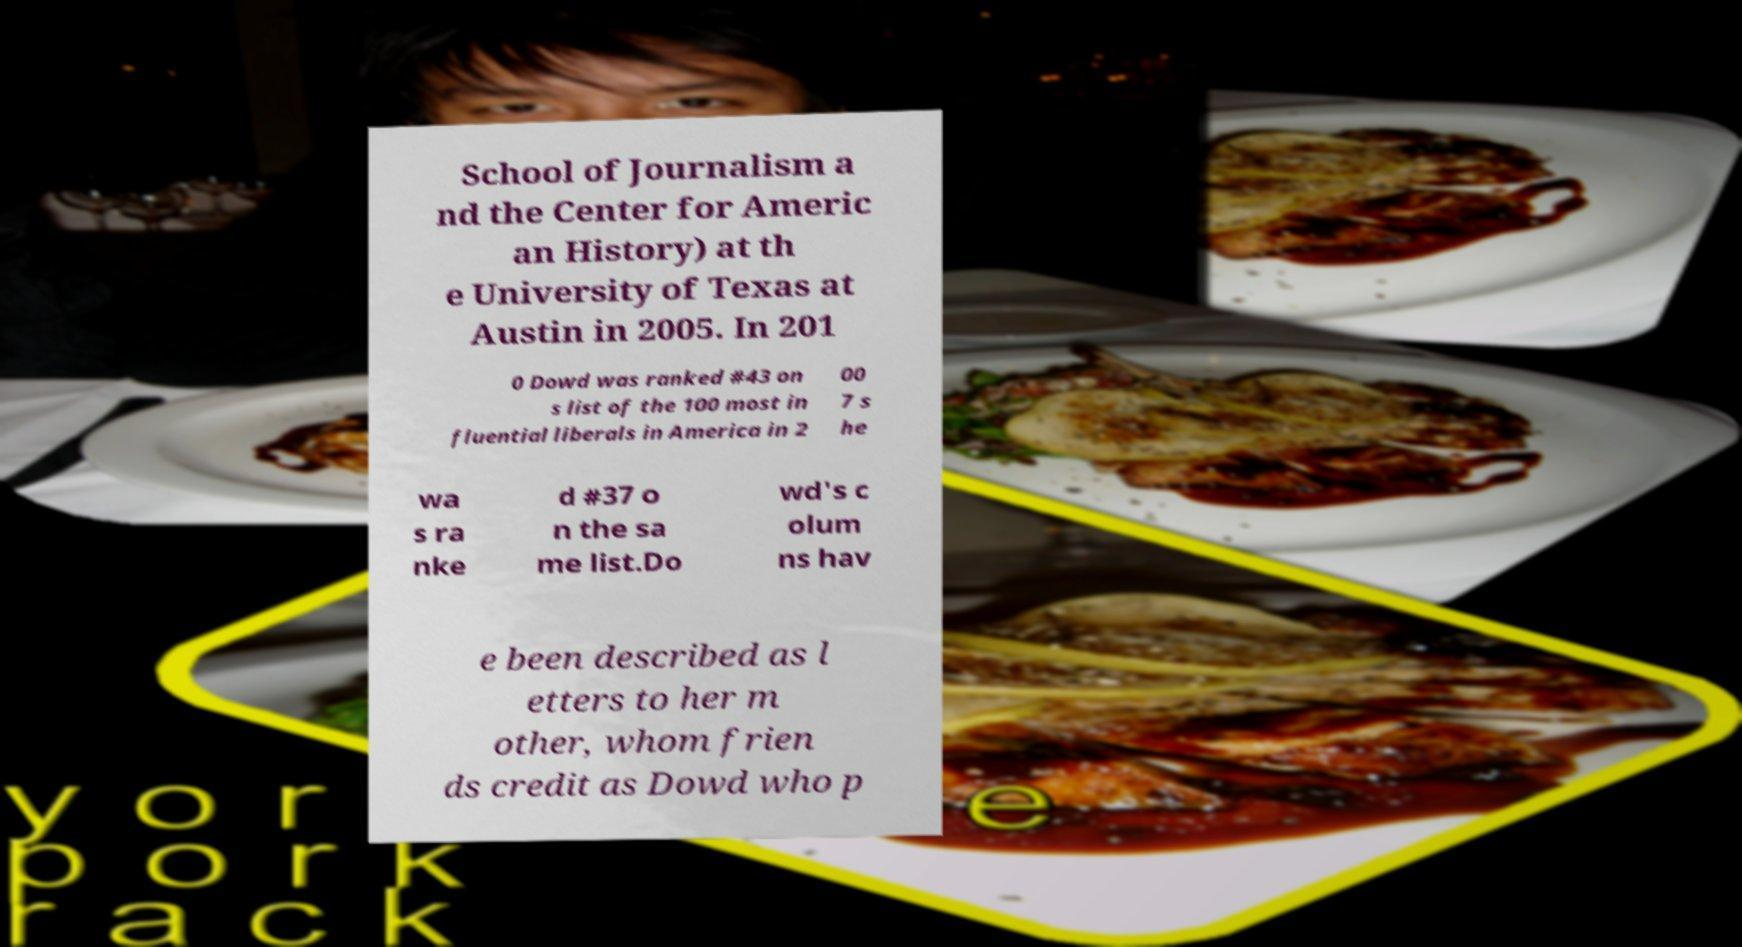Can you read and provide the text displayed in the image?This photo seems to have some interesting text. Can you extract and type it out for me? School of Journalism a nd the Center for Americ an History) at th e University of Texas at Austin in 2005. In 201 0 Dowd was ranked #43 on s list of the 100 most in fluential liberals in America in 2 00 7 s he wa s ra nke d #37 o n the sa me list.Do wd's c olum ns hav e been described as l etters to her m other, whom frien ds credit as Dowd who p 